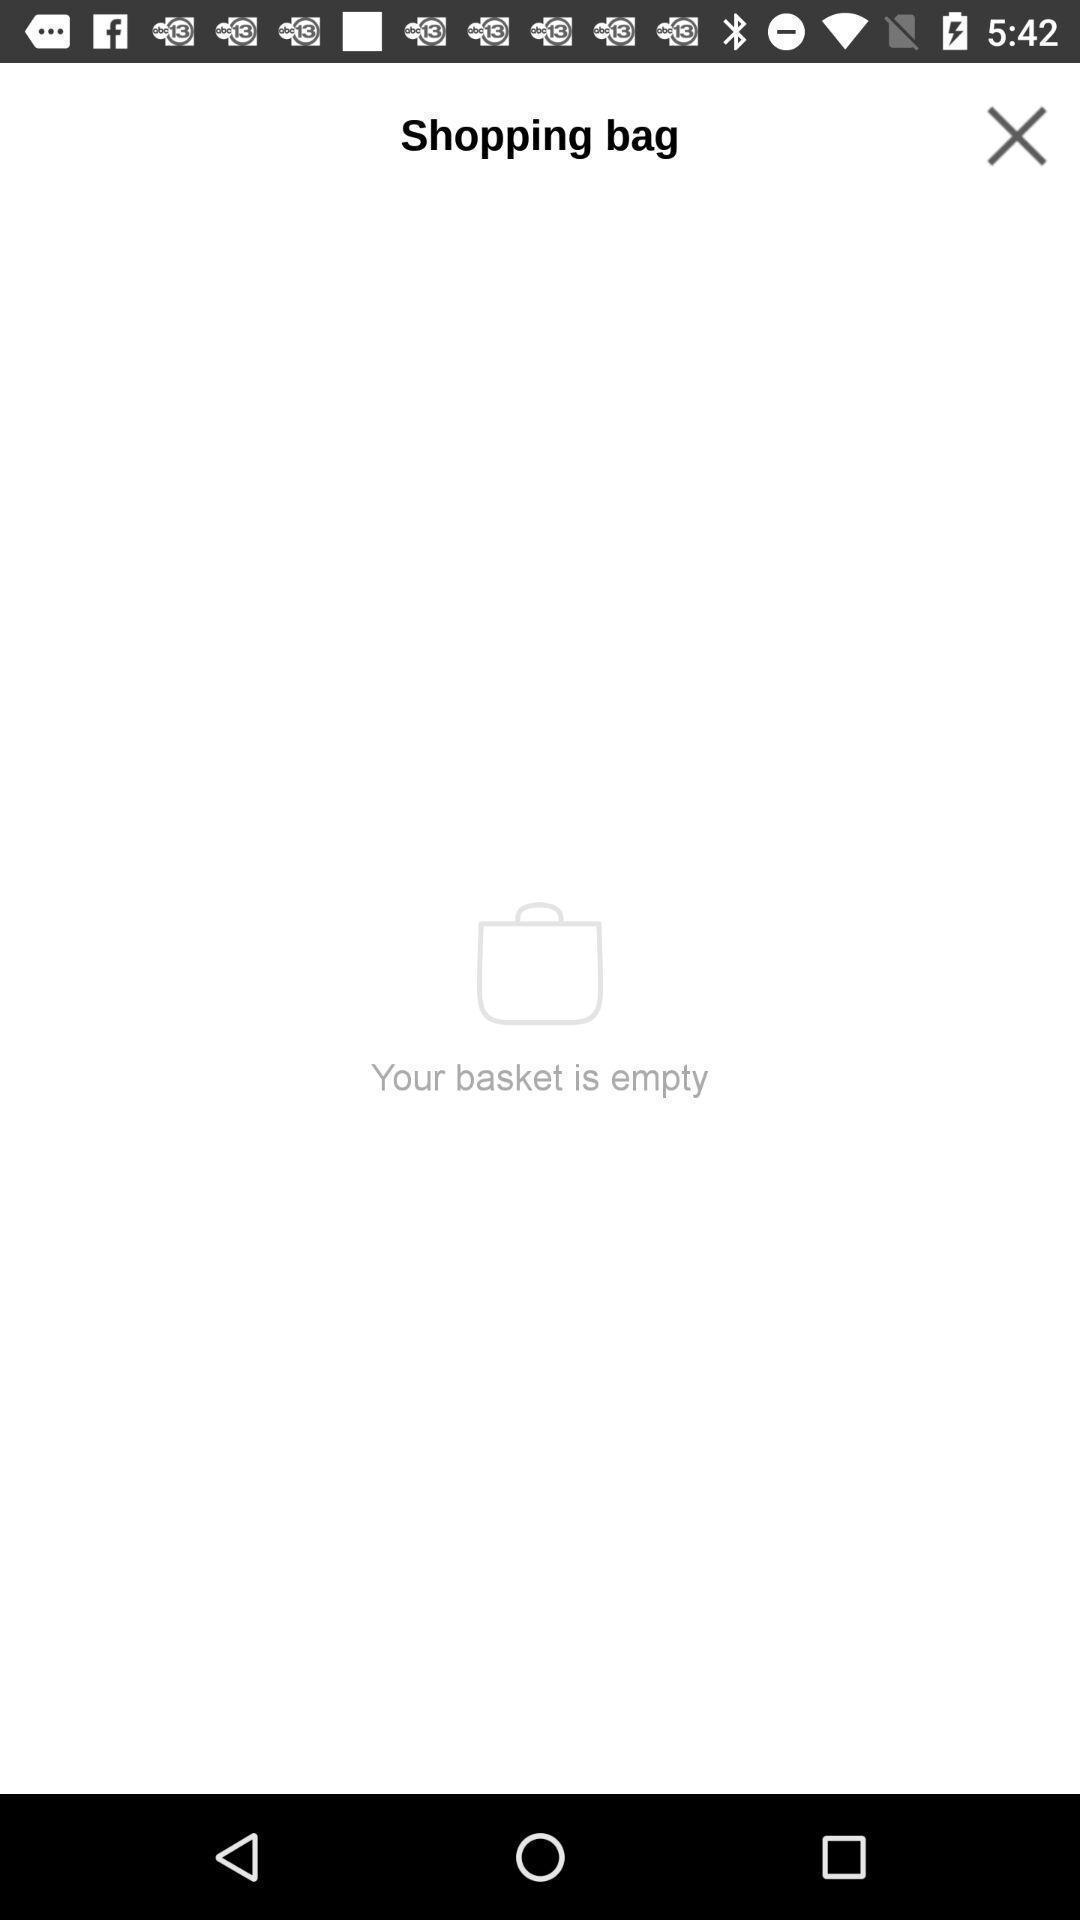Give me a narrative description of this picture. Screen shows shopping bag page. 